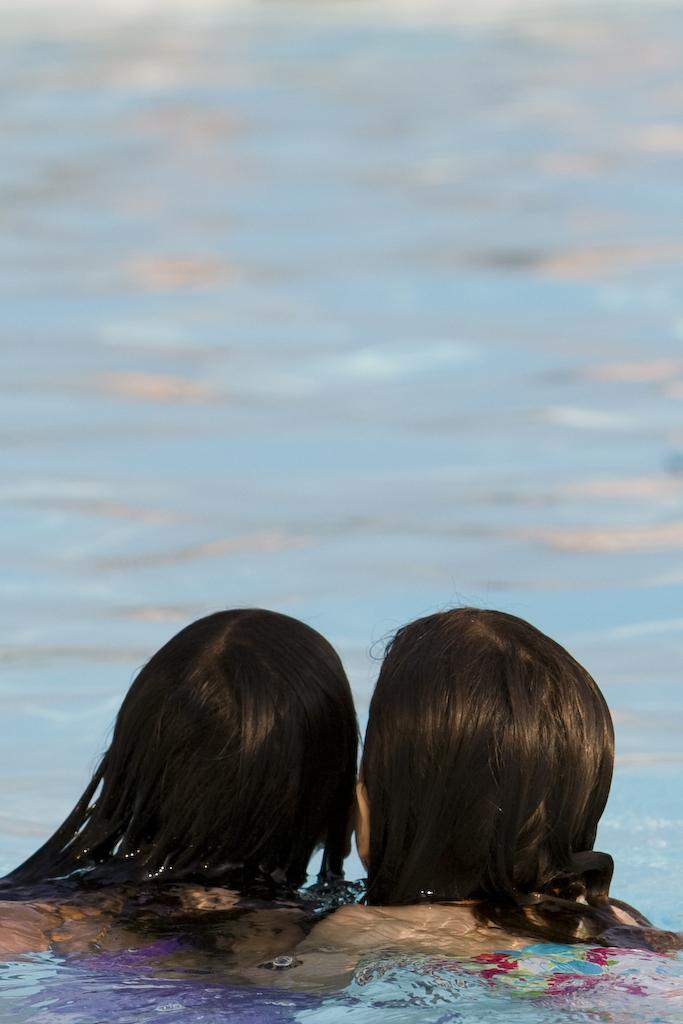How many people are present in the image? There are two women present in the image. What is the primary setting of the image? The women are in the water. What type of building can be seen in the background of the image? There is no building visible in the image, as it features two women in the water. What is the function of the mine in the image? There is no mine present in the image. What part of the brain can be seen in the image? There is no part of the brain visible in the image, as it features two women in the water. 